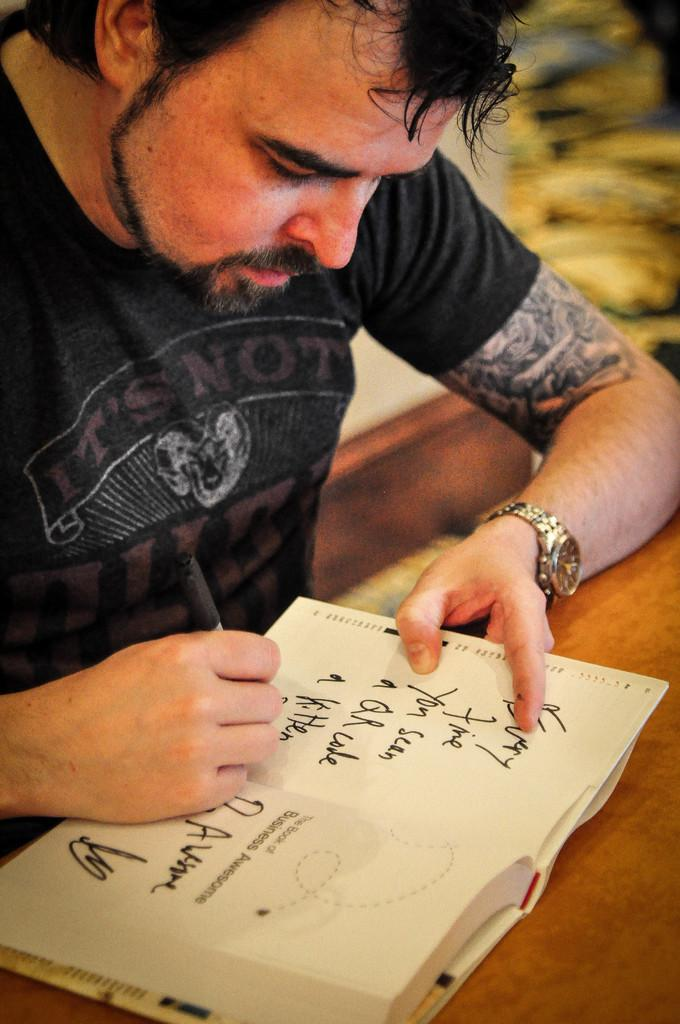What is the person in the image doing? The person is holding a pen and writing on a book. What object is the person using to write? The person is using a pen to write. Where is the image taken? The image is taken in a room. What type of weather is present in the image? There is no indication of weather in the image, as it is taken indoors in a room. 